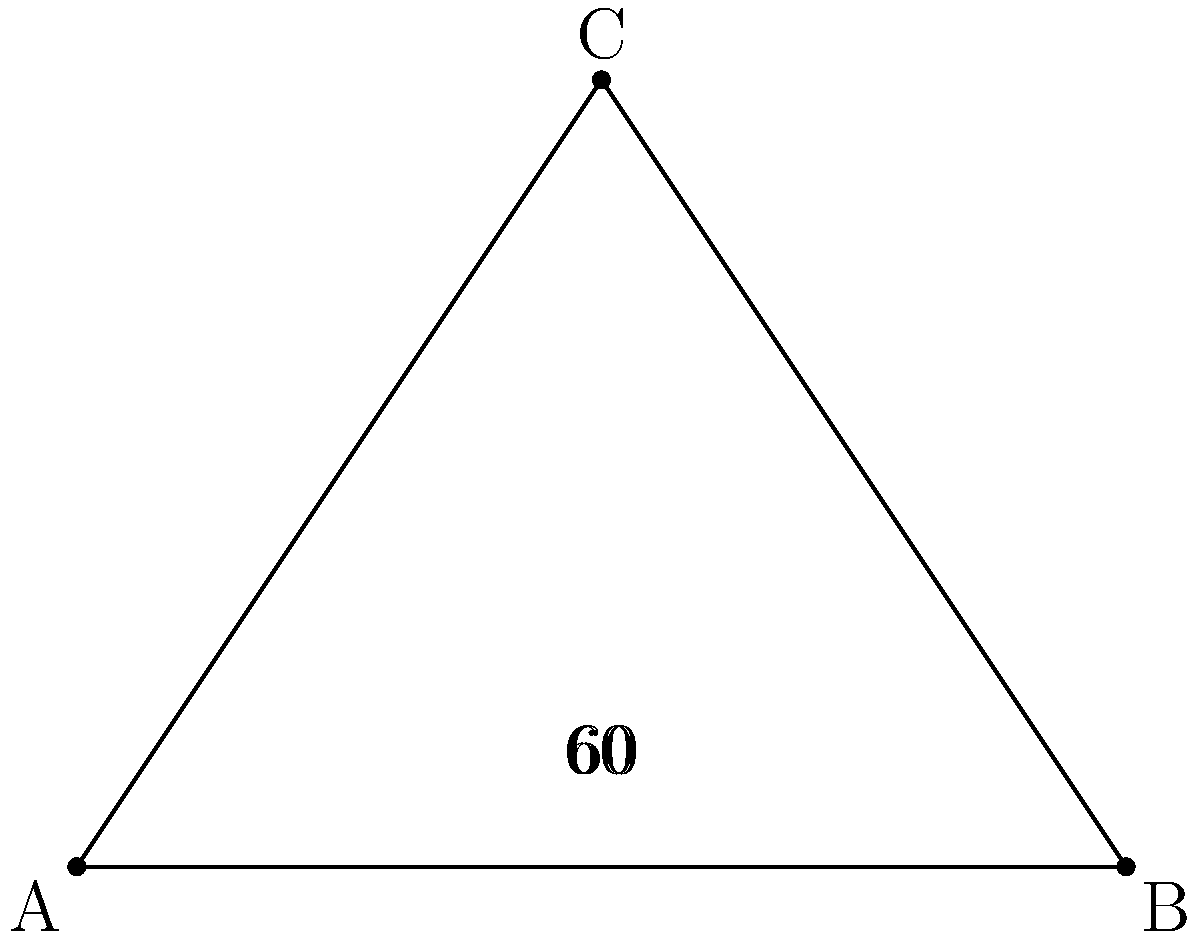You're experimenting with a new lacing pattern on your limited edition Swedish-themed sneakers. The laces form an equilateral triangle ABC, where C is the top eyelet and AB is the line between the bottom two eyelets. If the angle between each shoelace and the line AB is 60°, what is the measure of angle ACB? Let's approach this step-by-step:

1) First, recall that in an equilateral triangle, all sides are equal and all angles are equal.

2) We're given that the angles between each shoelace (AC and BC) and the base (AB) are 60°.

3) In a triangle, the sum of all angles is always 180°. Let's call the angle ACB that we're looking for x°.

4) We can set up an equation:
   $60° + 60° + x° = 180°$

5) Simplifying:
   $120° + x° = 180°$

6) Subtracting 120° from both sides:
   $x° = 180° - 120° = 60°$

Therefore, the measure of angle ACB is 60°.

This makes sense because in an equilateral triangle, all angles are equal and measure 60°.
Answer: 60° 